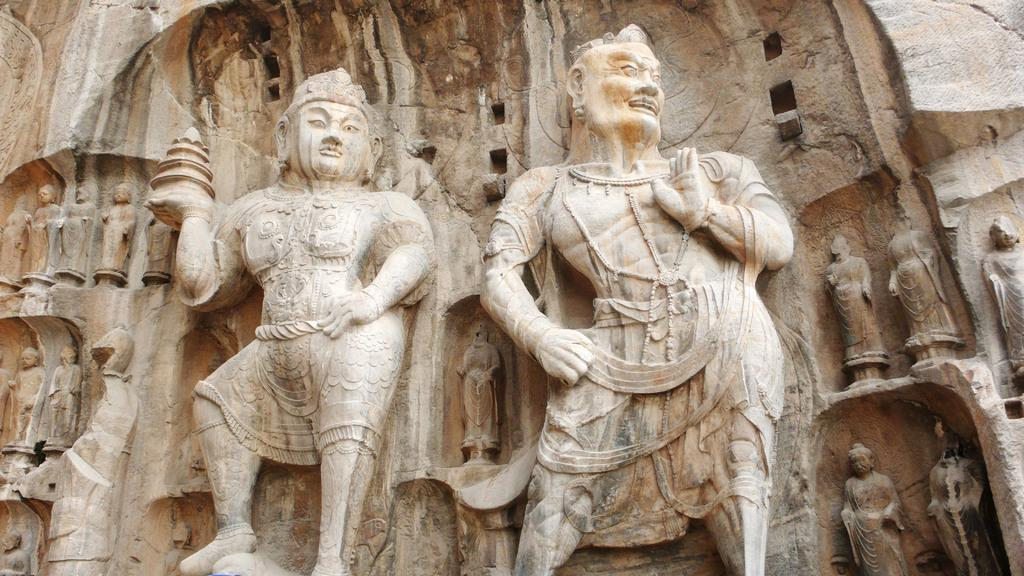What type of art or design can be seen in the image? There are stone carvings in the image. Can you describe the material used for the carvings? The carvings are made of stone. What might be the purpose or significance of these stone carvings? The purpose or significance of the stone carvings cannot be determined from the image alone, but they may have cultural, historical, or artistic value. What type of thread is used to create the stone carvings in the image? There is no thread used in the creation of the stone carvings; they are made by carving or sculpting the stone. 